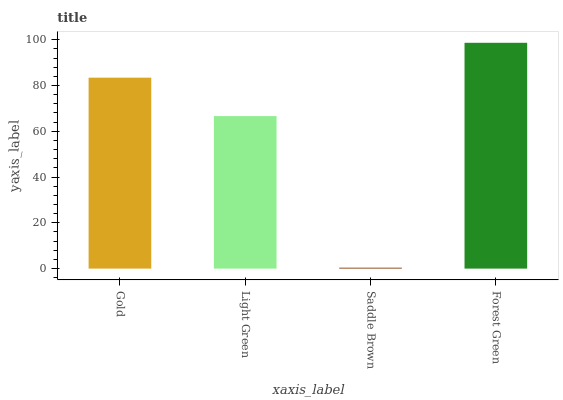Is Saddle Brown the minimum?
Answer yes or no. Yes. Is Forest Green the maximum?
Answer yes or no. Yes. Is Light Green the minimum?
Answer yes or no. No. Is Light Green the maximum?
Answer yes or no. No. Is Gold greater than Light Green?
Answer yes or no. Yes. Is Light Green less than Gold?
Answer yes or no. Yes. Is Light Green greater than Gold?
Answer yes or no. No. Is Gold less than Light Green?
Answer yes or no. No. Is Gold the high median?
Answer yes or no. Yes. Is Light Green the low median?
Answer yes or no. Yes. Is Light Green the high median?
Answer yes or no. No. Is Forest Green the low median?
Answer yes or no. No. 